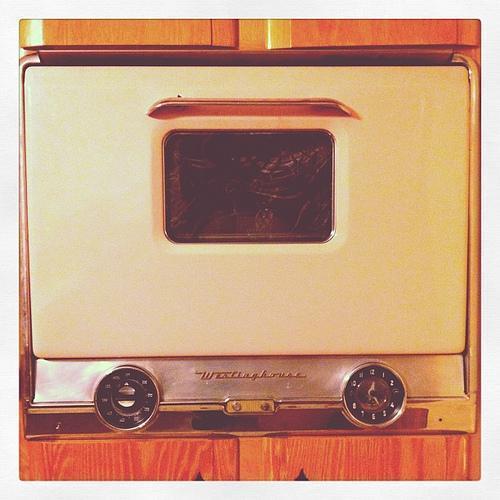How many dials are there?
Give a very brief answer. 2. 